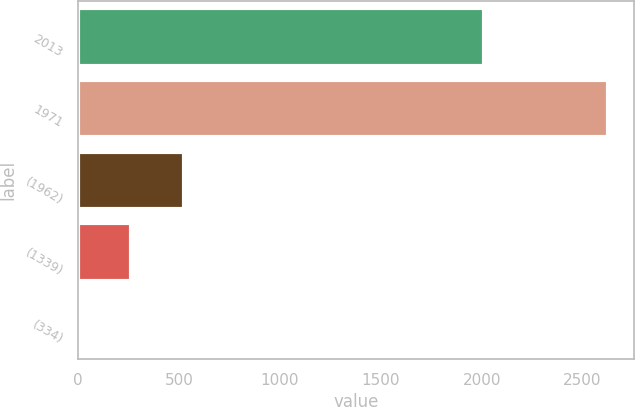<chart> <loc_0><loc_0><loc_500><loc_500><bar_chart><fcel>2013<fcel>1971<fcel>(1962)<fcel>(1339)<fcel>(334)<nl><fcel>2013<fcel>2624<fcel>525.21<fcel>262.86<fcel>0.51<nl></chart> 